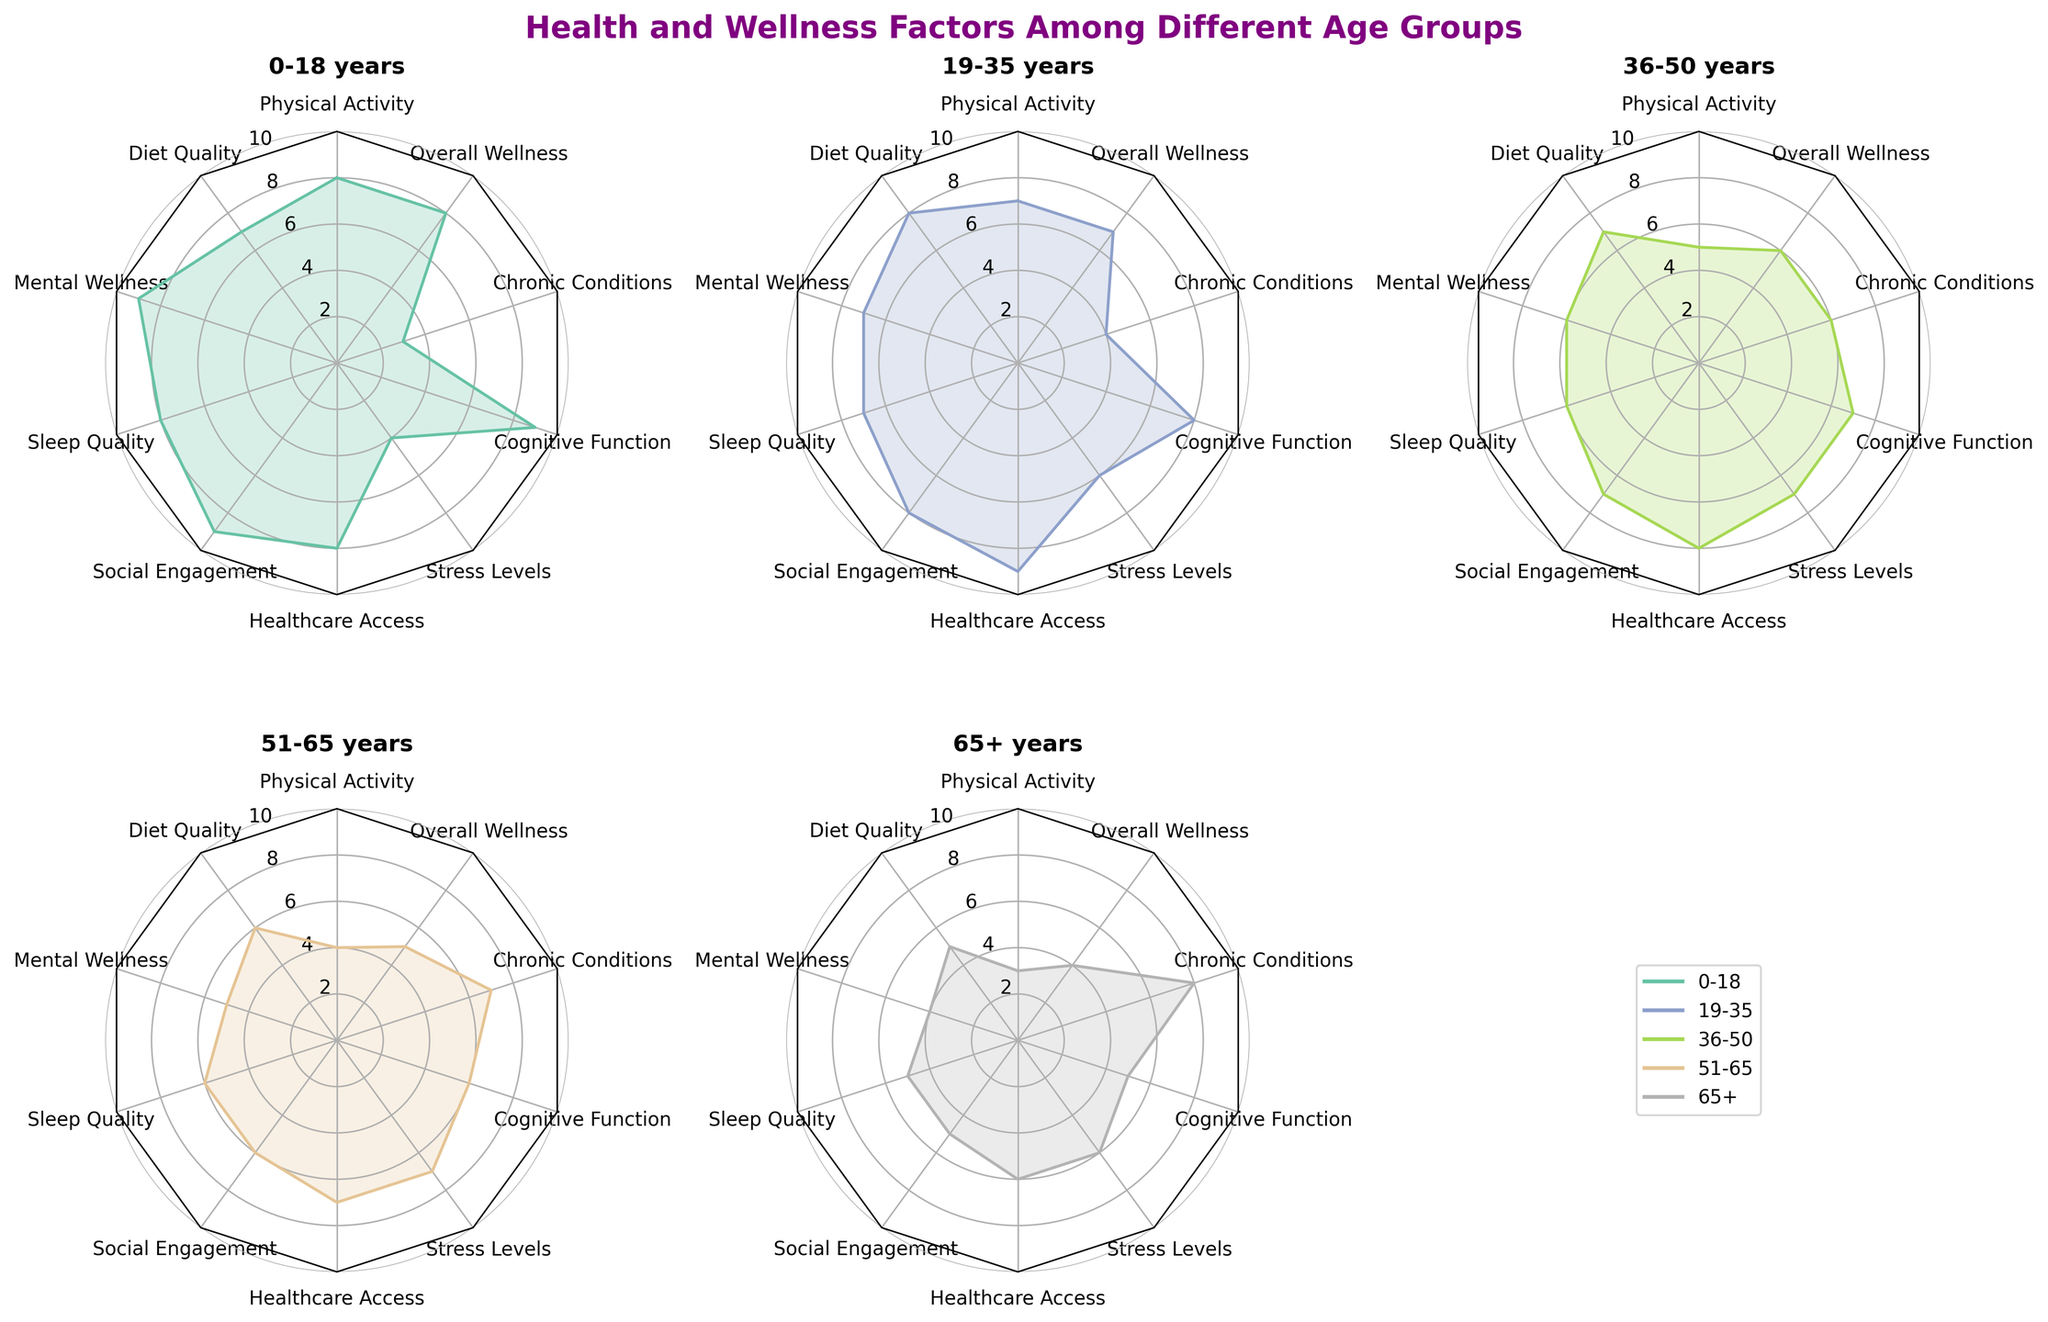Which age group has the highest value for Physical Activity? To find the highest value for Physical Activity, we look at the radar chart for each age group's score in this category. The 0-18 age group has the highest value of 8 for Physical Activity.
Answer: 0-18 Is Sleep Quality for the 36-50 age group higher, lower, or equal compared to Social Engagement in the same age group? By examining the radar chart for the values corresponding to the 36-50 age group, we see that Sleep Quality has a value of 6 and Social Engagement also has a value of 7. Thus, Sleep Quality is lower.
Answer: Lower What's the average Mental Wellness score among all age groups? To find the average Mental Wellness score, we add the values for each age group (9 + 7 + 6 + 5 + 4) and divide by the number of age groups. Sum = 31, so the average is 31/5 = 6.2
Answer: 6.2 Which category shows the most significant decline from the youngest to the oldest age group? By examining the radar chart, we need to look at the difference in scores from the 0-18 group to the 65+ group across all categories. Chronic Conditions have the most significant decline, going from a score of 9 to 5, resulting in a decline of 4 points.
Answer: Chronic Conditions Where do we see the highest Stress Levels, and how does it compare to the Physical Activity for the same age group? By inspecting the radar charts, the 36-50 age group has the highest Stress Level with a score of 7. This value is compared with the Physical Activity score of the same age group, which is 5. Stress Levels are higher.
Answer: 36-50; higher Rank the age groups from highest to lowest in terms of Social Engagement. Examining the radar chart, the values for Social Engagement for each age group are: 0-18 (9), 19-35 (8), 36-50 (7), 51-65 (6), and 65+ (5). Ranking from highest to lowest is: 0-18, 19-35, 36-50, 51-65, 65+.
Answer: 0-18, 19-35, 36-50, 51-65, 65+ In which category do age groups have the most uniform scores, and what’s the range of values? Looking at the radar charts, the values for Healthcare Access across age groups are quite uniform: 8, 9, 8, 7, and 6. The range of values is 3 (9-6).
Answer: Healthcare Access; 3 If we calculate the difference between the highest and lowest value in Diet Quality, what do we get? To find the difference, check the radar charts for each age group's score in Diet Quality: 7, 8, 7, 6, and 5. The highest value is 8, and the lowest value is 5. The difference is 8 - 5 = 3.
Answer: 3 Comparing Mental Wellness and Cognitive Function for ages 0-18, which category scores higher and by how much? By examining the radar chart for the 0-18 age group, the Mental Wellness score is 9, and Cognitive Function is also 9. Therefore, the scores are equal, and the difference is 0.
Answer: Equal; 0 What's the combined score for Sleep Quality and Stress Levels for the 51-65 age group? By inspecting the radar charts, the Sleep Quality for the 51-65 age group is 6, and Stress Levels are 7. Combined, the score is 6 + 7 = 13.
Answer: 13 